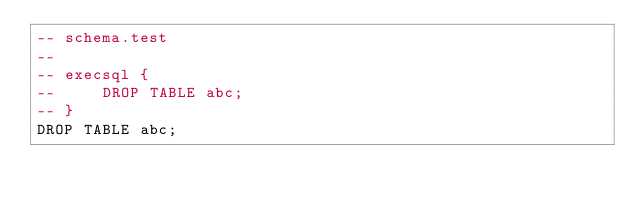Convert code to text. <code><loc_0><loc_0><loc_500><loc_500><_SQL_>-- schema.test
-- 
-- execsql {
--     DROP TABLE abc;
-- }
DROP TABLE abc;</code> 